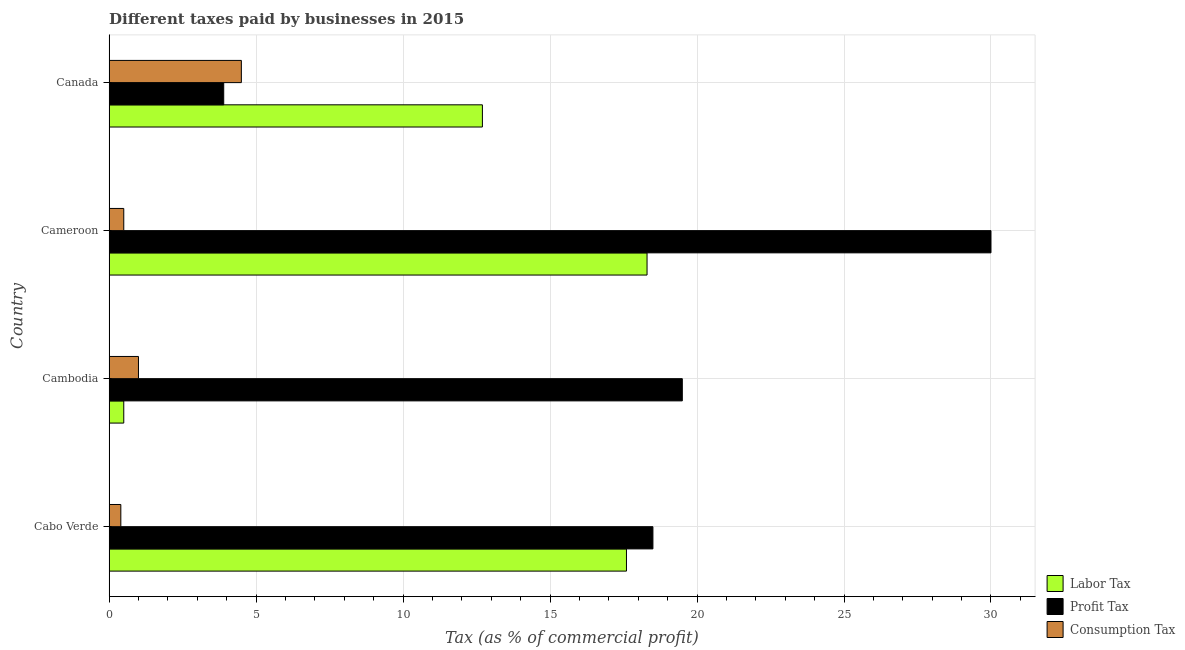How many different coloured bars are there?
Offer a terse response. 3. How many groups of bars are there?
Ensure brevity in your answer.  4. Are the number of bars per tick equal to the number of legend labels?
Make the answer very short. Yes. Are the number of bars on each tick of the Y-axis equal?
Make the answer very short. Yes. How many bars are there on the 1st tick from the top?
Your answer should be compact. 3. What is the label of the 3rd group of bars from the top?
Offer a terse response. Cambodia. In how many cases, is the number of bars for a given country not equal to the number of legend labels?
Provide a succinct answer. 0. In which country was the percentage of labor tax maximum?
Offer a very short reply. Cameroon. In which country was the percentage of profit tax minimum?
Keep it short and to the point. Canada. What is the total percentage of labor tax in the graph?
Offer a terse response. 49.1. What is the difference between the percentage of profit tax and percentage of consumption tax in Cambodia?
Give a very brief answer. 18.5. What is the ratio of the percentage of labor tax in Cambodia to that in Canada?
Your answer should be compact. 0.04. What is the difference between the highest and the lowest percentage of profit tax?
Offer a very short reply. 26.1. In how many countries, is the percentage of profit tax greater than the average percentage of profit tax taken over all countries?
Ensure brevity in your answer.  3. What does the 1st bar from the top in Cabo Verde represents?
Ensure brevity in your answer.  Consumption Tax. What does the 1st bar from the bottom in Canada represents?
Offer a terse response. Labor Tax. How many bars are there?
Offer a very short reply. 12. Are all the bars in the graph horizontal?
Offer a terse response. Yes. Are the values on the major ticks of X-axis written in scientific E-notation?
Ensure brevity in your answer.  No. Does the graph contain any zero values?
Offer a terse response. No. Does the graph contain grids?
Your response must be concise. Yes. How are the legend labels stacked?
Your answer should be very brief. Vertical. What is the title of the graph?
Ensure brevity in your answer.  Different taxes paid by businesses in 2015. Does "Czech Republic" appear as one of the legend labels in the graph?
Your answer should be very brief. No. What is the label or title of the X-axis?
Ensure brevity in your answer.  Tax (as % of commercial profit). What is the label or title of the Y-axis?
Provide a short and direct response. Country. What is the Tax (as % of commercial profit) in Profit Tax in Cambodia?
Keep it short and to the point. 19.5. What is the Tax (as % of commercial profit) in Labor Tax in Cameroon?
Make the answer very short. 18.3. What is the Tax (as % of commercial profit) in Consumption Tax in Cameroon?
Offer a very short reply. 0.5. What is the Tax (as % of commercial profit) of Labor Tax in Canada?
Keep it short and to the point. 12.7. What is the Tax (as % of commercial profit) of Consumption Tax in Canada?
Make the answer very short. 4.5. Across all countries, what is the maximum Tax (as % of commercial profit) of Labor Tax?
Give a very brief answer. 18.3. Across all countries, what is the minimum Tax (as % of commercial profit) of Profit Tax?
Your answer should be very brief. 3.9. What is the total Tax (as % of commercial profit) of Labor Tax in the graph?
Provide a short and direct response. 49.1. What is the total Tax (as % of commercial profit) of Profit Tax in the graph?
Offer a terse response. 71.9. What is the difference between the Tax (as % of commercial profit) of Labor Tax in Cabo Verde and that in Cambodia?
Your answer should be very brief. 17.1. What is the difference between the Tax (as % of commercial profit) of Profit Tax in Cabo Verde and that in Cambodia?
Offer a very short reply. -1. What is the difference between the Tax (as % of commercial profit) of Consumption Tax in Cabo Verde and that in Cambodia?
Make the answer very short. -0.6. What is the difference between the Tax (as % of commercial profit) of Profit Tax in Cabo Verde and that in Cameroon?
Provide a succinct answer. -11.5. What is the difference between the Tax (as % of commercial profit) of Consumption Tax in Cabo Verde and that in Cameroon?
Offer a very short reply. -0.1. What is the difference between the Tax (as % of commercial profit) in Profit Tax in Cabo Verde and that in Canada?
Offer a terse response. 14.6. What is the difference between the Tax (as % of commercial profit) in Labor Tax in Cambodia and that in Cameroon?
Offer a terse response. -17.8. What is the difference between the Tax (as % of commercial profit) of Consumption Tax in Cambodia and that in Canada?
Offer a terse response. -3.5. What is the difference between the Tax (as % of commercial profit) in Profit Tax in Cameroon and that in Canada?
Your answer should be compact. 26.1. What is the difference between the Tax (as % of commercial profit) of Consumption Tax in Cameroon and that in Canada?
Offer a terse response. -4. What is the difference between the Tax (as % of commercial profit) in Labor Tax in Cabo Verde and the Tax (as % of commercial profit) in Consumption Tax in Cambodia?
Offer a terse response. 16.6. What is the difference between the Tax (as % of commercial profit) of Profit Tax in Cabo Verde and the Tax (as % of commercial profit) of Consumption Tax in Cambodia?
Ensure brevity in your answer.  17.5. What is the difference between the Tax (as % of commercial profit) of Profit Tax in Cabo Verde and the Tax (as % of commercial profit) of Consumption Tax in Cameroon?
Your answer should be compact. 18. What is the difference between the Tax (as % of commercial profit) of Labor Tax in Cabo Verde and the Tax (as % of commercial profit) of Profit Tax in Canada?
Offer a terse response. 13.7. What is the difference between the Tax (as % of commercial profit) in Labor Tax in Cabo Verde and the Tax (as % of commercial profit) in Consumption Tax in Canada?
Provide a short and direct response. 13.1. What is the difference between the Tax (as % of commercial profit) of Labor Tax in Cambodia and the Tax (as % of commercial profit) of Profit Tax in Cameroon?
Provide a short and direct response. -29.5. What is the difference between the Tax (as % of commercial profit) of Profit Tax in Cambodia and the Tax (as % of commercial profit) of Consumption Tax in Cameroon?
Make the answer very short. 19. What is the difference between the Tax (as % of commercial profit) in Labor Tax in Cameroon and the Tax (as % of commercial profit) in Profit Tax in Canada?
Your response must be concise. 14.4. What is the difference between the Tax (as % of commercial profit) of Profit Tax in Cameroon and the Tax (as % of commercial profit) of Consumption Tax in Canada?
Ensure brevity in your answer.  25.5. What is the average Tax (as % of commercial profit) in Labor Tax per country?
Offer a very short reply. 12.28. What is the average Tax (as % of commercial profit) of Profit Tax per country?
Ensure brevity in your answer.  17.98. What is the average Tax (as % of commercial profit) in Consumption Tax per country?
Make the answer very short. 1.6. What is the difference between the Tax (as % of commercial profit) of Labor Tax and Tax (as % of commercial profit) of Consumption Tax in Cabo Verde?
Offer a terse response. 17.2. What is the difference between the Tax (as % of commercial profit) in Labor Tax and Tax (as % of commercial profit) in Consumption Tax in Cameroon?
Your response must be concise. 17.8. What is the difference between the Tax (as % of commercial profit) of Profit Tax and Tax (as % of commercial profit) of Consumption Tax in Cameroon?
Offer a terse response. 29.5. What is the difference between the Tax (as % of commercial profit) of Labor Tax and Tax (as % of commercial profit) of Profit Tax in Canada?
Make the answer very short. 8.8. What is the difference between the Tax (as % of commercial profit) of Labor Tax and Tax (as % of commercial profit) of Consumption Tax in Canada?
Ensure brevity in your answer.  8.2. What is the difference between the Tax (as % of commercial profit) in Profit Tax and Tax (as % of commercial profit) in Consumption Tax in Canada?
Keep it short and to the point. -0.6. What is the ratio of the Tax (as % of commercial profit) in Labor Tax in Cabo Verde to that in Cambodia?
Provide a short and direct response. 35.2. What is the ratio of the Tax (as % of commercial profit) in Profit Tax in Cabo Verde to that in Cambodia?
Make the answer very short. 0.95. What is the ratio of the Tax (as % of commercial profit) of Labor Tax in Cabo Verde to that in Cameroon?
Provide a succinct answer. 0.96. What is the ratio of the Tax (as % of commercial profit) of Profit Tax in Cabo Verde to that in Cameroon?
Give a very brief answer. 0.62. What is the ratio of the Tax (as % of commercial profit) in Consumption Tax in Cabo Verde to that in Cameroon?
Provide a short and direct response. 0.8. What is the ratio of the Tax (as % of commercial profit) of Labor Tax in Cabo Verde to that in Canada?
Your answer should be very brief. 1.39. What is the ratio of the Tax (as % of commercial profit) of Profit Tax in Cabo Verde to that in Canada?
Your answer should be very brief. 4.74. What is the ratio of the Tax (as % of commercial profit) in Consumption Tax in Cabo Verde to that in Canada?
Your answer should be very brief. 0.09. What is the ratio of the Tax (as % of commercial profit) of Labor Tax in Cambodia to that in Cameroon?
Your answer should be compact. 0.03. What is the ratio of the Tax (as % of commercial profit) of Profit Tax in Cambodia to that in Cameroon?
Provide a succinct answer. 0.65. What is the ratio of the Tax (as % of commercial profit) of Labor Tax in Cambodia to that in Canada?
Offer a very short reply. 0.04. What is the ratio of the Tax (as % of commercial profit) in Consumption Tax in Cambodia to that in Canada?
Offer a very short reply. 0.22. What is the ratio of the Tax (as % of commercial profit) in Labor Tax in Cameroon to that in Canada?
Give a very brief answer. 1.44. What is the ratio of the Tax (as % of commercial profit) in Profit Tax in Cameroon to that in Canada?
Make the answer very short. 7.69. What is the difference between the highest and the second highest Tax (as % of commercial profit) in Labor Tax?
Provide a short and direct response. 0.7. What is the difference between the highest and the second highest Tax (as % of commercial profit) of Profit Tax?
Ensure brevity in your answer.  10.5. What is the difference between the highest and the lowest Tax (as % of commercial profit) of Profit Tax?
Give a very brief answer. 26.1. What is the difference between the highest and the lowest Tax (as % of commercial profit) in Consumption Tax?
Your answer should be compact. 4.1. 